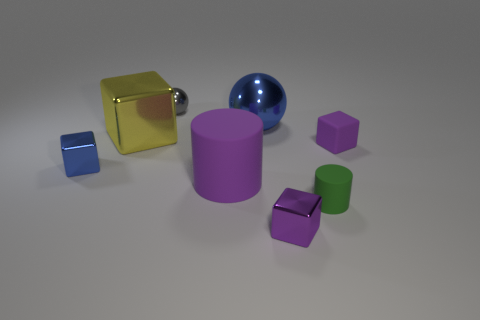How many cylinders are green rubber things or small gray metallic things?
Keep it short and to the point. 1. Is the large blue sphere made of the same material as the small blue thing?
Make the answer very short. Yes. The other metal object that is the same shape as the small gray shiny thing is what size?
Make the answer very short. Large. What is the object that is both on the left side of the small green object and in front of the large cylinder made of?
Keep it short and to the point. Metal. Are there an equal number of tiny rubber cubes behind the tiny gray sphere and cyan cylinders?
Make the answer very short. Yes. How many things are objects that are behind the large purple rubber cylinder or large rubber objects?
Give a very brief answer. 6. There is a small metallic block in front of the small blue metal thing; is its color the same as the small ball?
Your response must be concise. No. There is a purple rubber object that is to the left of the tiny cylinder; what is its size?
Offer a very short reply. Large. There is a small thing behind the purple rubber object that is to the right of the small rubber cylinder; what shape is it?
Make the answer very short. Sphere. What color is the small rubber thing that is the same shape as the big yellow shiny object?
Your answer should be compact. Purple. 